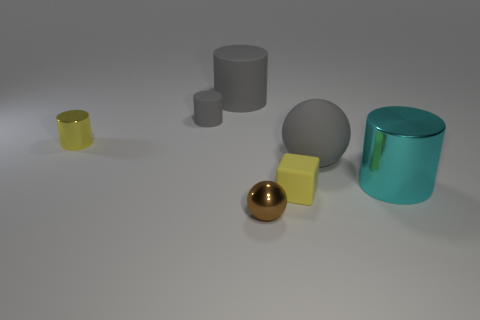Add 2 yellow matte things. How many objects exist? 9 Subtract all balls. How many objects are left? 5 Subtract all big metallic cylinders. Subtract all small metal balls. How many objects are left? 5 Add 1 shiny balls. How many shiny balls are left? 2 Add 3 big gray spheres. How many big gray spheres exist? 4 Subtract 0 brown blocks. How many objects are left? 7 